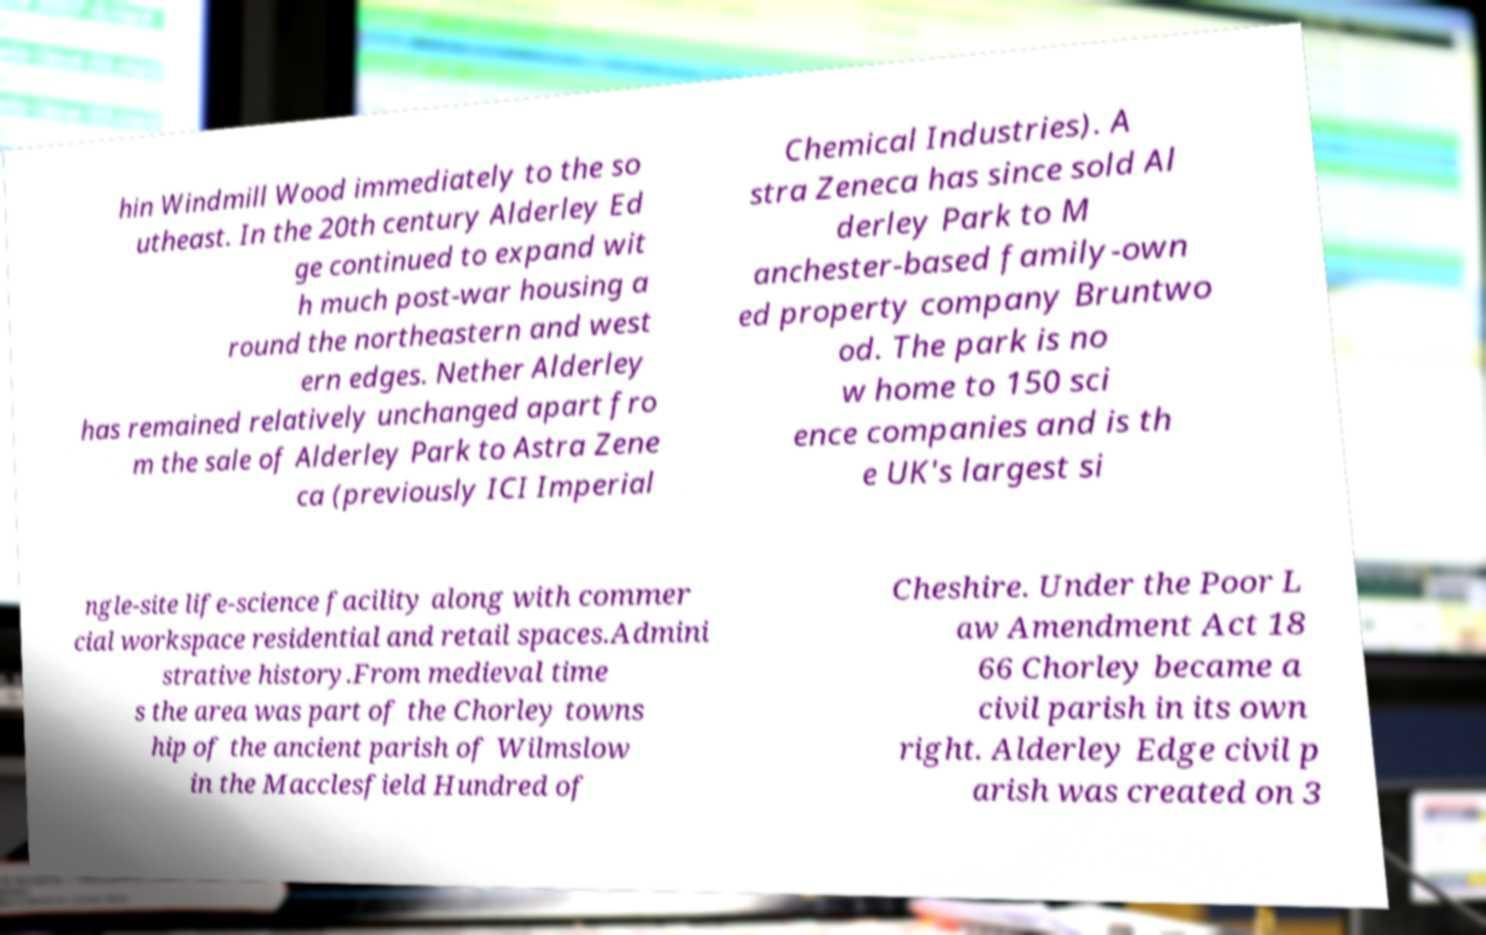I need the written content from this picture converted into text. Can you do that? hin Windmill Wood immediately to the so utheast. In the 20th century Alderley Ed ge continued to expand wit h much post-war housing a round the northeastern and west ern edges. Nether Alderley has remained relatively unchanged apart fro m the sale of Alderley Park to Astra Zene ca (previously ICI Imperial Chemical Industries). A stra Zeneca has since sold Al derley Park to M anchester-based family-own ed property company Bruntwo od. The park is no w home to 150 sci ence companies and is th e UK's largest si ngle-site life-science facility along with commer cial workspace residential and retail spaces.Admini strative history.From medieval time s the area was part of the Chorley towns hip of the ancient parish of Wilmslow in the Macclesfield Hundred of Cheshire. Under the Poor L aw Amendment Act 18 66 Chorley became a civil parish in its own right. Alderley Edge civil p arish was created on 3 